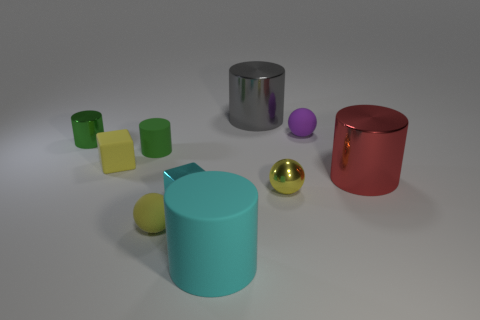What shape is the small shiny thing that is the same color as the small matte cylinder?
Keep it short and to the point. Cylinder. There is a object that is the same color as the metallic block; what is its size?
Your answer should be compact. Large. There is a red metal thing; is its shape the same as the green thing that is to the left of the small green matte cylinder?
Your answer should be very brief. Yes. There is a large object in front of the tiny yellow sphere on the right side of the tiny cyan cube to the right of the rubber cube; what is its material?
Provide a short and direct response. Rubber. How many small green cylinders are there?
Your answer should be compact. 2. How many cyan objects are tiny rubber spheres or large matte cylinders?
Ensure brevity in your answer.  1. What number of other things are the same shape as the small yellow metal object?
Provide a short and direct response. 2. There is a small matte sphere that is in front of the cyan metal block; is it the same color as the cube that is behind the tiny cyan cube?
Your answer should be very brief. Yes. What number of tiny objects are cyan metallic blocks or gray shiny cylinders?
Give a very brief answer. 1. The green matte object that is the same shape as the red shiny thing is what size?
Ensure brevity in your answer.  Small. 